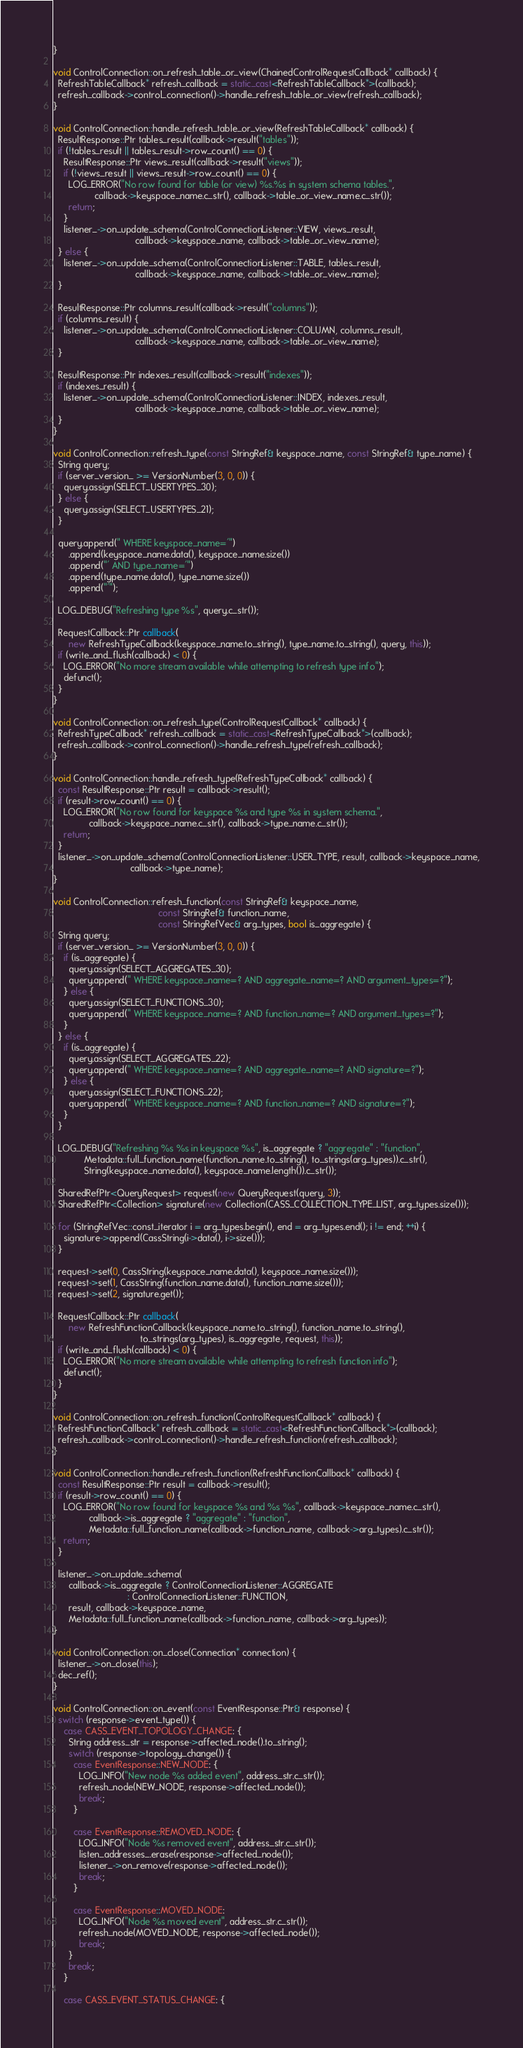<code> <loc_0><loc_0><loc_500><loc_500><_C++_>}

void ControlConnection::on_refresh_table_or_view(ChainedControlRequestCallback* callback) {
  RefreshTableCallback* refresh_callback = static_cast<RefreshTableCallback*>(callback);
  refresh_callback->control_connection()->handle_refresh_table_or_view(refresh_callback);
}

void ControlConnection::handle_refresh_table_or_view(RefreshTableCallback* callback) {
  ResultResponse::Ptr tables_result(callback->result("tables"));
  if (!tables_result || tables_result->row_count() == 0) {
    ResultResponse::Ptr views_result(callback->result("views"));
    if (!views_result || views_result->row_count() == 0) {
      LOG_ERROR("No row found for table (or view) %s.%s in system schema tables.",
                callback->keyspace_name.c_str(), callback->table_or_view_name.c_str());
      return;
    }
    listener_->on_update_schema(ControlConnectionListener::VIEW, views_result,
                                callback->keyspace_name, callback->table_or_view_name);
  } else {
    listener_->on_update_schema(ControlConnectionListener::TABLE, tables_result,
                                callback->keyspace_name, callback->table_or_view_name);
  }

  ResultResponse::Ptr columns_result(callback->result("columns"));
  if (columns_result) {
    listener_->on_update_schema(ControlConnectionListener::COLUMN, columns_result,
                                callback->keyspace_name, callback->table_or_view_name);
  }

  ResultResponse::Ptr indexes_result(callback->result("indexes"));
  if (indexes_result) {
    listener_->on_update_schema(ControlConnectionListener::INDEX, indexes_result,
                                callback->keyspace_name, callback->table_or_view_name);
  }
}

void ControlConnection::refresh_type(const StringRef& keyspace_name, const StringRef& type_name) {
  String query;
  if (server_version_ >= VersionNumber(3, 0, 0)) {
    query.assign(SELECT_USERTYPES_30);
  } else {
    query.assign(SELECT_USERTYPES_21);
  }

  query.append(" WHERE keyspace_name='")
      .append(keyspace_name.data(), keyspace_name.size())
      .append("' AND type_name='")
      .append(type_name.data(), type_name.size())
      .append("'");

  LOG_DEBUG("Refreshing type %s", query.c_str());

  RequestCallback::Ptr callback(
      new RefreshTypeCallback(keyspace_name.to_string(), type_name.to_string(), query, this));
  if (write_and_flush(callback) < 0) {
    LOG_ERROR("No more stream available while attempting to refresh type info");
    defunct();
  }
}

void ControlConnection::on_refresh_type(ControlRequestCallback* callback) {
  RefreshTypeCallback* refresh_callback = static_cast<RefreshTypeCallback*>(callback);
  refresh_callback->control_connection()->handle_refresh_type(refresh_callback);
}

void ControlConnection::handle_refresh_type(RefreshTypeCallback* callback) {
  const ResultResponse::Ptr result = callback->result();
  if (result->row_count() == 0) {
    LOG_ERROR("No row found for keyspace %s and type %s in system schema.",
              callback->keyspace_name.c_str(), callback->type_name.c_str());
    return;
  }
  listener_->on_update_schema(ControlConnectionListener::USER_TYPE, result, callback->keyspace_name,
                              callback->type_name);
}

void ControlConnection::refresh_function(const StringRef& keyspace_name,
                                         const StringRef& function_name,
                                         const StringRefVec& arg_types, bool is_aggregate) {
  String query;
  if (server_version_ >= VersionNumber(3, 0, 0)) {
    if (is_aggregate) {
      query.assign(SELECT_AGGREGATES_30);
      query.append(" WHERE keyspace_name=? AND aggregate_name=? AND argument_types=?");
    } else {
      query.assign(SELECT_FUNCTIONS_30);
      query.append(" WHERE keyspace_name=? AND function_name=? AND argument_types=?");
    }
  } else {
    if (is_aggregate) {
      query.assign(SELECT_AGGREGATES_22);
      query.append(" WHERE keyspace_name=? AND aggregate_name=? AND signature=?");
    } else {
      query.assign(SELECT_FUNCTIONS_22);
      query.append(" WHERE keyspace_name=? AND function_name=? AND signature=?");
    }
  }

  LOG_DEBUG("Refreshing %s %s in keyspace %s", is_aggregate ? "aggregate" : "function",
            Metadata::full_function_name(function_name.to_string(), to_strings(arg_types)).c_str(),
            String(keyspace_name.data(), keyspace_name.length()).c_str());

  SharedRefPtr<QueryRequest> request(new QueryRequest(query, 3));
  SharedRefPtr<Collection> signature(new Collection(CASS_COLLECTION_TYPE_LIST, arg_types.size()));

  for (StringRefVec::const_iterator i = arg_types.begin(), end = arg_types.end(); i != end; ++i) {
    signature->append(CassString(i->data(), i->size()));
  }

  request->set(0, CassString(keyspace_name.data(), keyspace_name.size()));
  request->set(1, CassString(function_name.data(), function_name.size()));
  request->set(2, signature.get());

  RequestCallback::Ptr callback(
      new RefreshFunctionCallback(keyspace_name.to_string(), function_name.to_string(),
                                  to_strings(arg_types), is_aggregate, request, this));
  if (write_and_flush(callback) < 0) {
    LOG_ERROR("No more stream available while attempting to refresh function info");
    defunct();
  }
}

void ControlConnection::on_refresh_function(ControlRequestCallback* callback) {
  RefreshFunctionCallback* refresh_callback = static_cast<RefreshFunctionCallback*>(callback);
  refresh_callback->control_connection()->handle_refresh_function(refresh_callback);
}

void ControlConnection::handle_refresh_function(RefreshFunctionCallback* callback) {
  const ResultResponse::Ptr result = callback->result();
  if (result->row_count() == 0) {
    LOG_ERROR("No row found for keyspace %s and %s %s", callback->keyspace_name.c_str(),
              callback->is_aggregate ? "aggregate" : "function",
              Metadata::full_function_name(callback->function_name, callback->arg_types).c_str());
    return;
  }

  listener_->on_update_schema(
      callback->is_aggregate ? ControlConnectionListener::AGGREGATE
                             : ControlConnectionListener::FUNCTION,
      result, callback->keyspace_name,
      Metadata::full_function_name(callback->function_name, callback->arg_types));
}

void ControlConnection::on_close(Connection* connection) {
  listener_->on_close(this);
  dec_ref();
}

void ControlConnection::on_event(const EventResponse::Ptr& response) {
  switch (response->event_type()) {
    case CASS_EVENT_TOPOLOGY_CHANGE: {
      String address_str = response->affected_node().to_string();
      switch (response->topology_change()) {
        case EventResponse::NEW_NODE: {
          LOG_INFO("New node %s added event", address_str.c_str());
          refresh_node(NEW_NODE, response->affected_node());
          break;
        }

        case EventResponse::REMOVED_NODE: {
          LOG_INFO("Node %s removed event", address_str.c_str());
          listen_addresses_.erase(response->affected_node());
          listener_->on_remove(response->affected_node());
          break;
        }

        case EventResponse::MOVED_NODE:
          LOG_INFO("Node %s moved event", address_str.c_str());
          refresh_node(MOVED_NODE, response->affected_node());
          break;
      }
      break;
    }

    case CASS_EVENT_STATUS_CHANGE: {</code> 